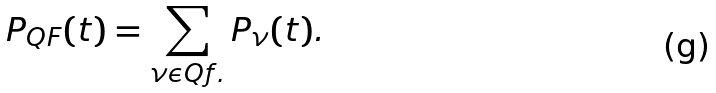Convert formula to latex. <formula><loc_0><loc_0><loc_500><loc_500>P _ { Q F } ( t ) = \sum _ { \nu \mathcal { \epsilon } Q f . } P _ { \nu } ( t ) .</formula> 